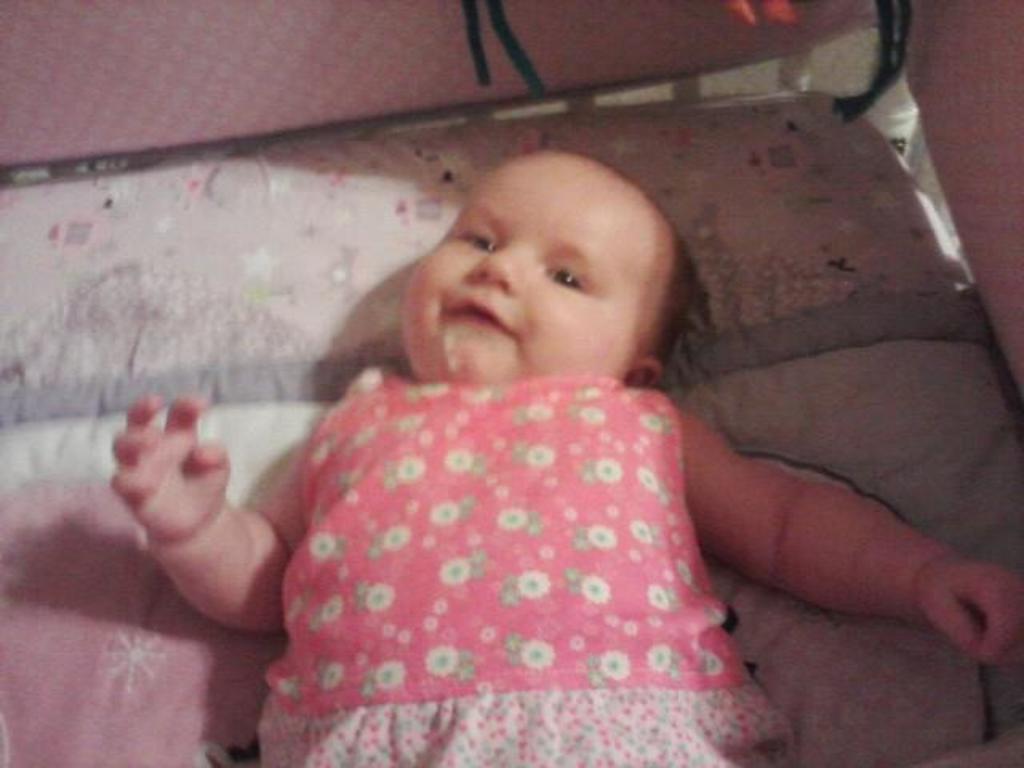How would you summarize this image in a sentence or two? In this image I can see a child in the centre and I can see this child is wearing pink colour dress. 